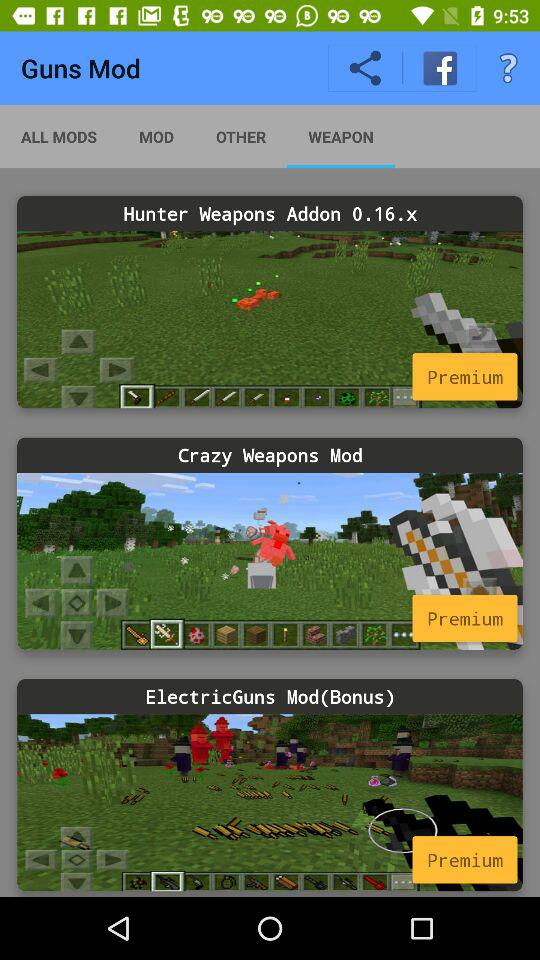How many mods have a screenshot of a minecraft game?
Answer the question using a single word or phrase. 3 